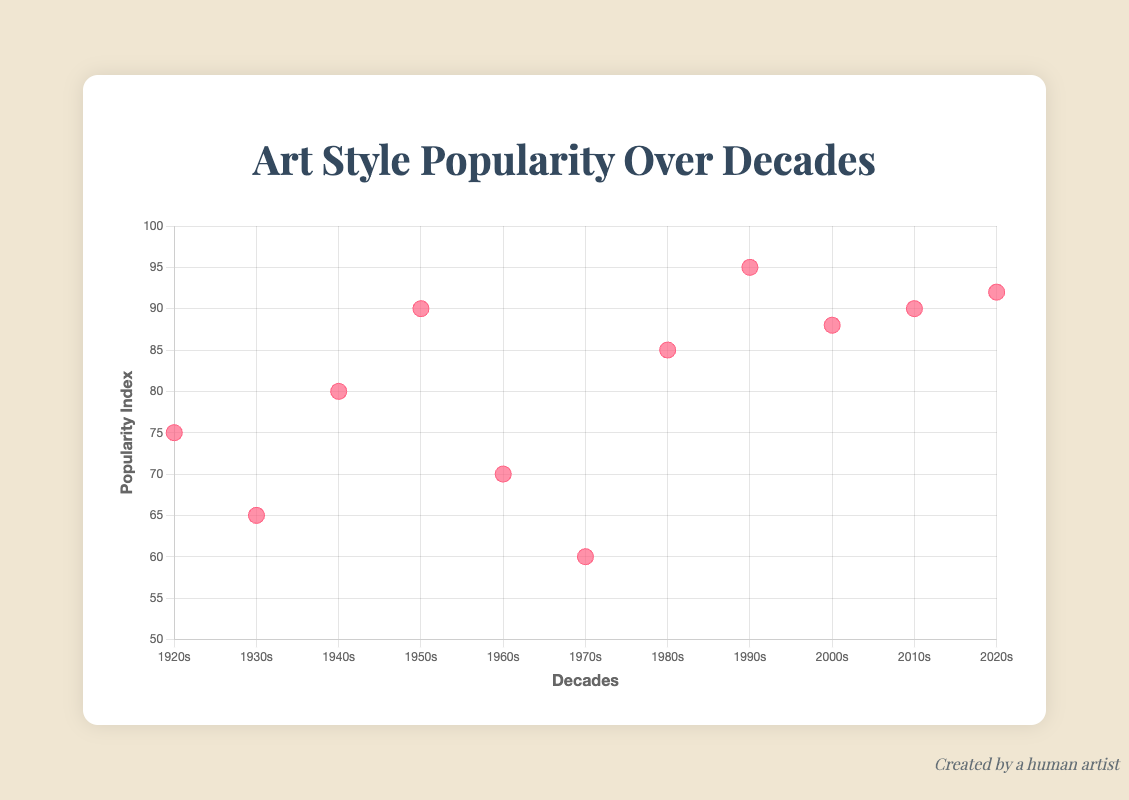What is the title of the chart? The title is located near the top center of the chart, in a large bold font.
Answer: Art Style Popularity Over Decades How many decades are represented in the chart? The x-axis of the scatter plot shows ticks corresponding to each decade, from the 1920s to the 2020s. Each tick represents a decade. By counting the ticks on the x-axis, we can see there are 11 decades represented.
Answer: 11 Which decade has the highest popularity index? By looking at the y-axis, we can see the vertical positions of the data points. The highest data point corresponds to the highest y-value. The data point at the highest y-value belongs to the 1990s as indicated by tooltips and labels.
Answer: 1990s What is the trend of art style popularity over the decades? The trend line in the chart shows the general direction of the data points. It is a straight line with a positive slope, indicating that overall, art style popularity has been increasing over the decades.
Answer: Increasing Which decades have a popularity index greater than 90? Identify the data points that exceed the 90 mark on the y-axis. The data points higher than 90 are those corresponding to the 1990s, 2010s, and 2020s.
Answer: 1990s, 2010s, 2020s How did the popularity of art styles change during periods of major cultural events? Observing the data points in conjunction with the influential events associated with each, we see how each major cultural event corresponds to changes in popularity indices. For example, during the Great Depression in the 1930s, the popularity index was lower compared to the 1920s and 2010s. Each influential event provides context for the rise and fall of these indices.
Answer: Variably, depending on the events Compare the popularity indices of art styles during World War II and the Cryptocurrency Surge. The popularity index for the 1940s, during World War II, is 80. The index for the 2020s, influenced by the Cryptocurrency Surge, is 92. Comparing these values, the index is higher during the Cryptocurrency Surge.
Answer: Higher in the 2020s Describe how the popularity index of Art Deco in the 1920s compares to Minimalism in the 1960s. Examine the positions of the two data points' y-values on the chart. Art Deco in the 1920s has a popularity index of 75, and Minimalism in the 1960s has a lower value of 70. This indicates Art Deco was more popular in its respective decade.
Answer: Art Deco is higher What can be inferred about the impact of the Digital Revolution on art styles? The Digital Revolution took place in the 1990s. The corresponding data point shows the highest popularity index of 95. This suggests a significant boost in the popularity of art styles due to the Digital Revolution.
Answer: Significant boost Find the average popularity index over all decades. Sum the popularity indices of all recorded decades (75 + 65 + 80 + 90 + 70 + 60 + 85 + 95 + 88 + 90 + 92), which equals 890. Divide this sum by the number of decades, which is 11. The average popularity index is 890 / 11.
Answer: 81 